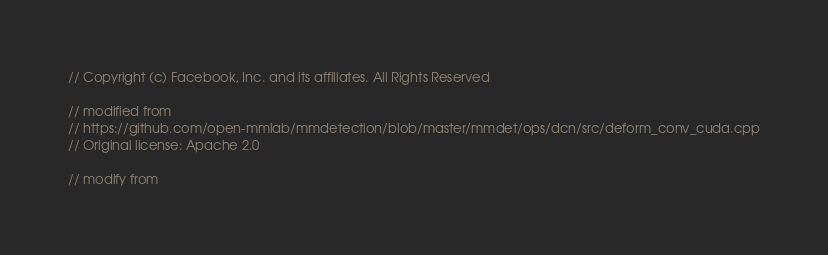Convert code to text. <code><loc_0><loc_0><loc_500><loc_500><_Cuda_>// Copyright (c) Facebook, Inc. and its affiliates. All Rights Reserved

// modified from
// https://github.com/open-mmlab/mmdetection/blob/master/mmdet/ops/dcn/src/deform_conv_cuda.cpp
// Original license: Apache 2.0

// modify from</code> 